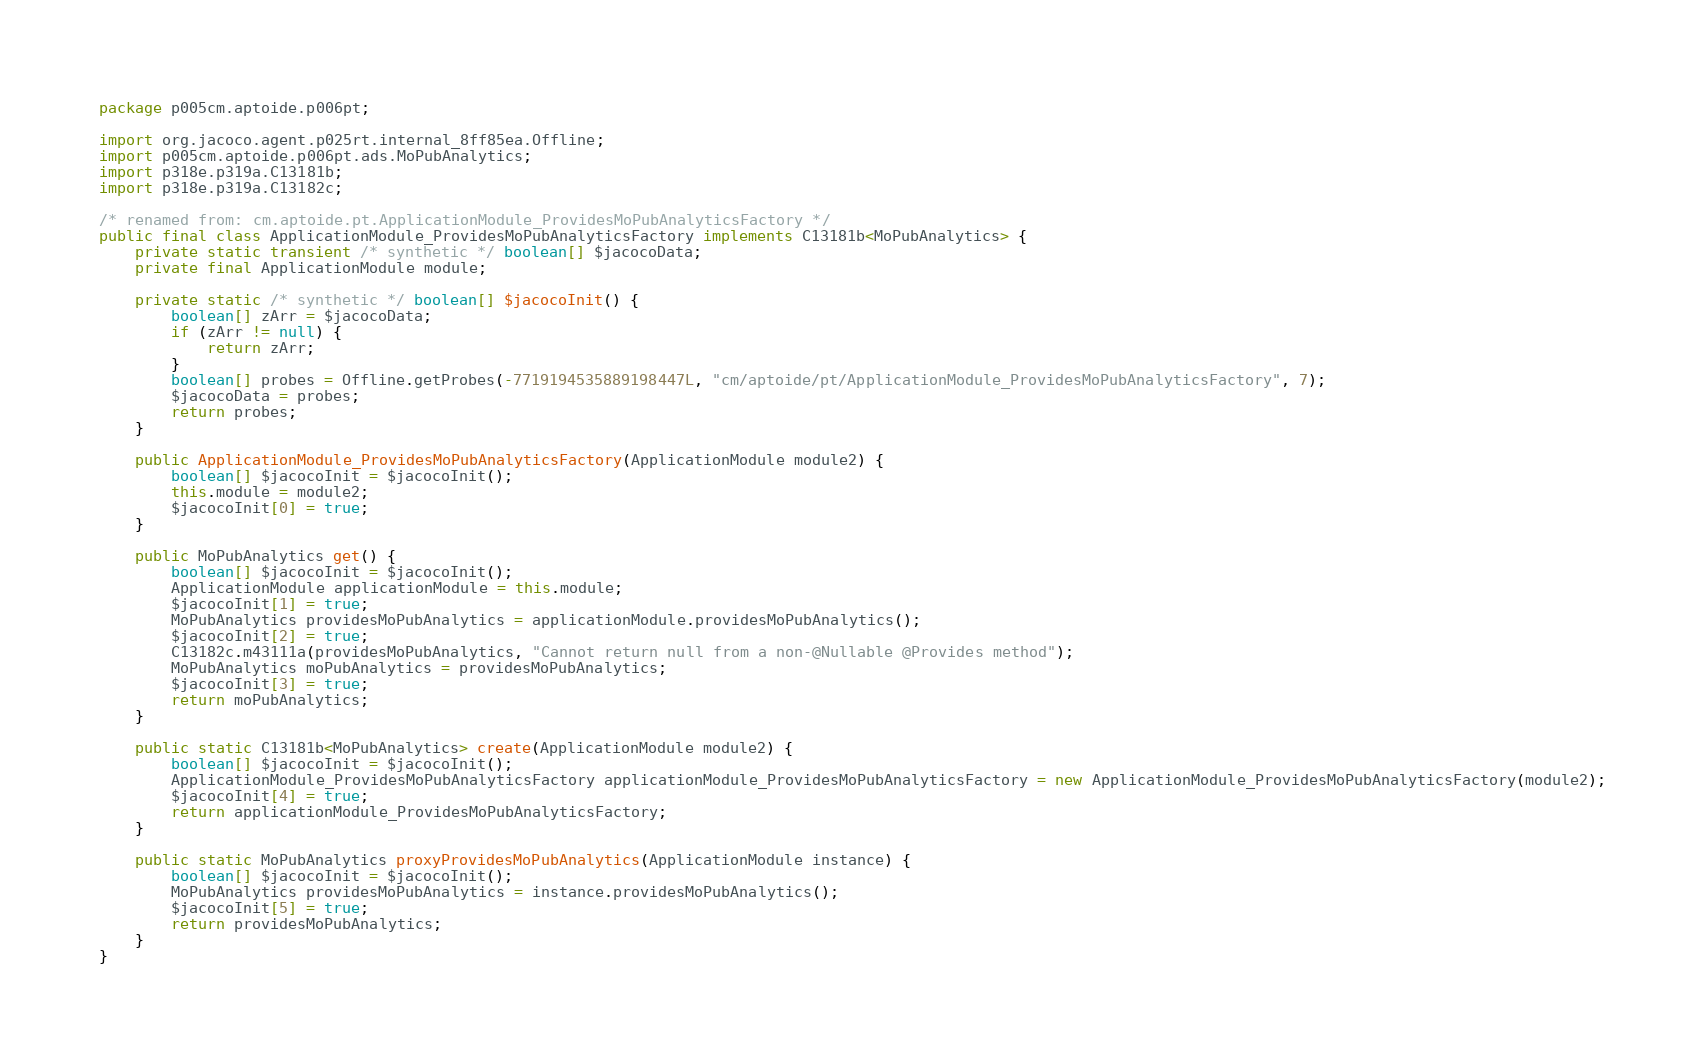Convert code to text. <code><loc_0><loc_0><loc_500><loc_500><_Java_>package p005cm.aptoide.p006pt;

import org.jacoco.agent.p025rt.internal_8ff85ea.Offline;
import p005cm.aptoide.p006pt.ads.MoPubAnalytics;
import p318e.p319a.C13181b;
import p318e.p319a.C13182c;

/* renamed from: cm.aptoide.pt.ApplicationModule_ProvidesMoPubAnalyticsFactory */
public final class ApplicationModule_ProvidesMoPubAnalyticsFactory implements C13181b<MoPubAnalytics> {
    private static transient /* synthetic */ boolean[] $jacocoData;
    private final ApplicationModule module;

    private static /* synthetic */ boolean[] $jacocoInit() {
        boolean[] zArr = $jacocoData;
        if (zArr != null) {
            return zArr;
        }
        boolean[] probes = Offline.getProbes(-7719194535889198447L, "cm/aptoide/pt/ApplicationModule_ProvidesMoPubAnalyticsFactory", 7);
        $jacocoData = probes;
        return probes;
    }

    public ApplicationModule_ProvidesMoPubAnalyticsFactory(ApplicationModule module2) {
        boolean[] $jacocoInit = $jacocoInit();
        this.module = module2;
        $jacocoInit[0] = true;
    }

    public MoPubAnalytics get() {
        boolean[] $jacocoInit = $jacocoInit();
        ApplicationModule applicationModule = this.module;
        $jacocoInit[1] = true;
        MoPubAnalytics providesMoPubAnalytics = applicationModule.providesMoPubAnalytics();
        $jacocoInit[2] = true;
        C13182c.m43111a(providesMoPubAnalytics, "Cannot return null from a non-@Nullable @Provides method");
        MoPubAnalytics moPubAnalytics = providesMoPubAnalytics;
        $jacocoInit[3] = true;
        return moPubAnalytics;
    }

    public static C13181b<MoPubAnalytics> create(ApplicationModule module2) {
        boolean[] $jacocoInit = $jacocoInit();
        ApplicationModule_ProvidesMoPubAnalyticsFactory applicationModule_ProvidesMoPubAnalyticsFactory = new ApplicationModule_ProvidesMoPubAnalyticsFactory(module2);
        $jacocoInit[4] = true;
        return applicationModule_ProvidesMoPubAnalyticsFactory;
    }

    public static MoPubAnalytics proxyProvidesMoPubAnalytics(ApplicationModule instance) {
        boolean[] $jacocoInit = $jacocoInit();
        MoPubAnalytics providesMoPubAnalytics = instance.providesMoPubAnalytics();
        $jacocoInit[5] = true;
        return providesMoPubAnalytics;
    }
}
</code> 